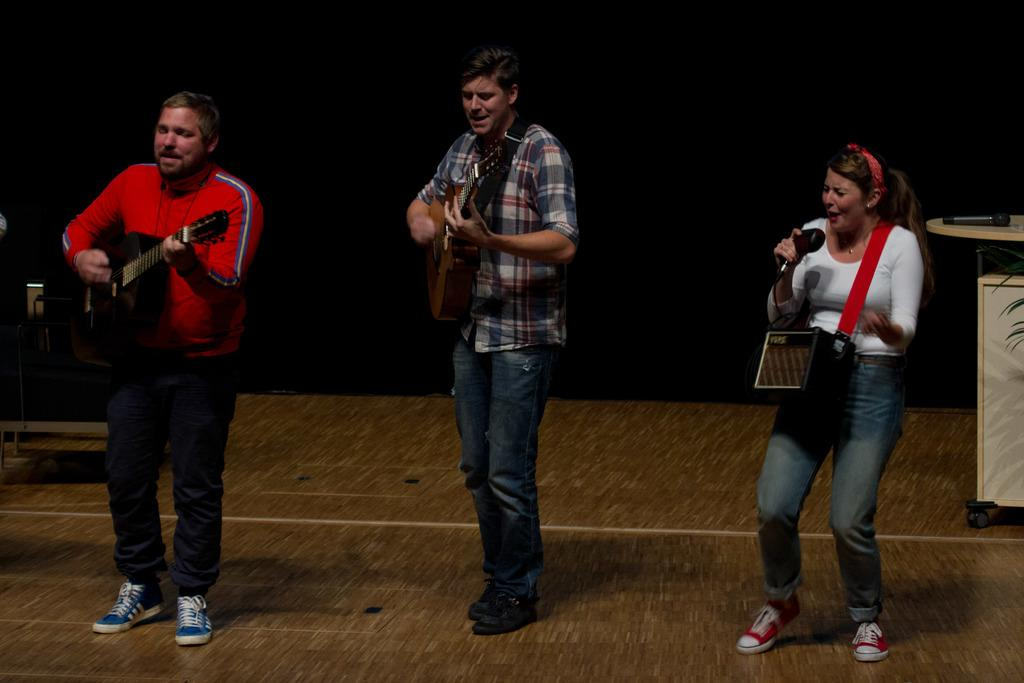How many people are in the image? There are three people in the image. What are the two men holding in the image? The two men are holding guitars. What is the woman holding in the image? The woman is holding a microphone. Can you see a monkey playing the drums in the image? No, there is no monkey or drums present in the image. What type of wheel is visible in the image? There is no wheel present in the image. 